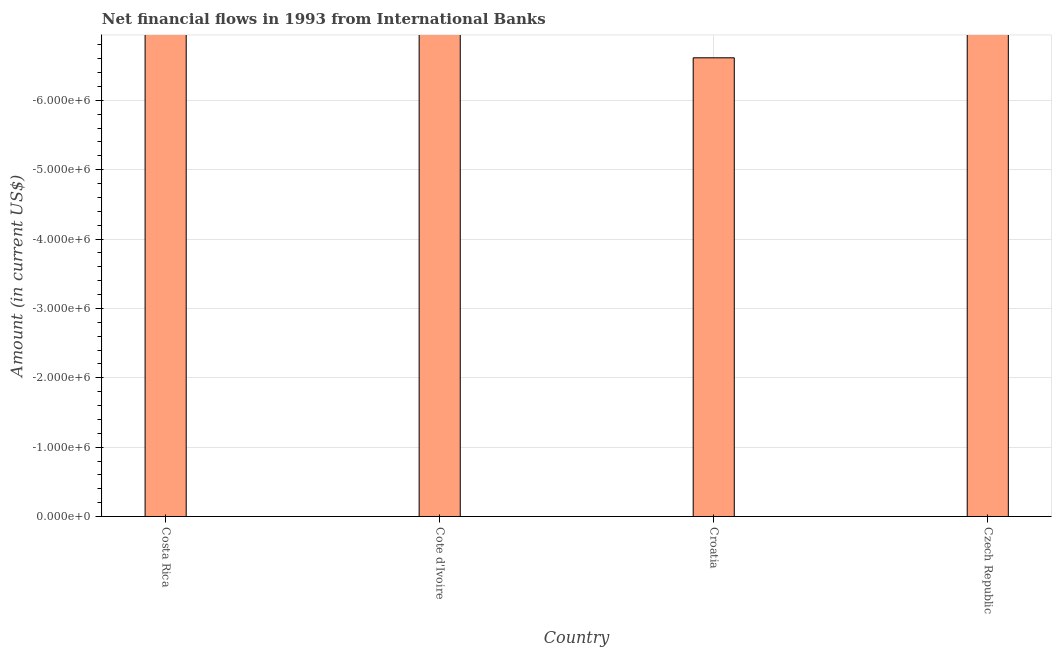Does the graph contain any zero values?
Offer a very short reply. Yes. Does the graph contain grids?
Give a very brief answer. Yes. What is the title of the graph?
Provide a succinct answer. Net financial flows in 1993 from International Banks. What is the label or title of the Y-axis?
Make the answer very short. Amount (in current US$). What is the net financial flows from ibrd in Cote d'Ivoire?
Provide a short and direct response. 0. In how many countries, is the net financial flows from ibrd greater than -5000000 US$?
Make the answer very short. 0. In how many countries, is the net financial flows from ibrd greater than the average net financial flows from ibrd taken over all countries?
Give a very brief answer. 0. What is the difference between two consecutive major ticks on the Y-axis?
Your answer should be very brief. 1.00e+06. What is the Amount (in current US$) in Costa Rica?
Offer a very short reply. 0. What is the Amount (in current US$) in Cote d'Ivoire?
Keep it short and to the point. 0. What is the Amount (in current US$) in Czech Republic?
Your answer should be very brief. 0. 